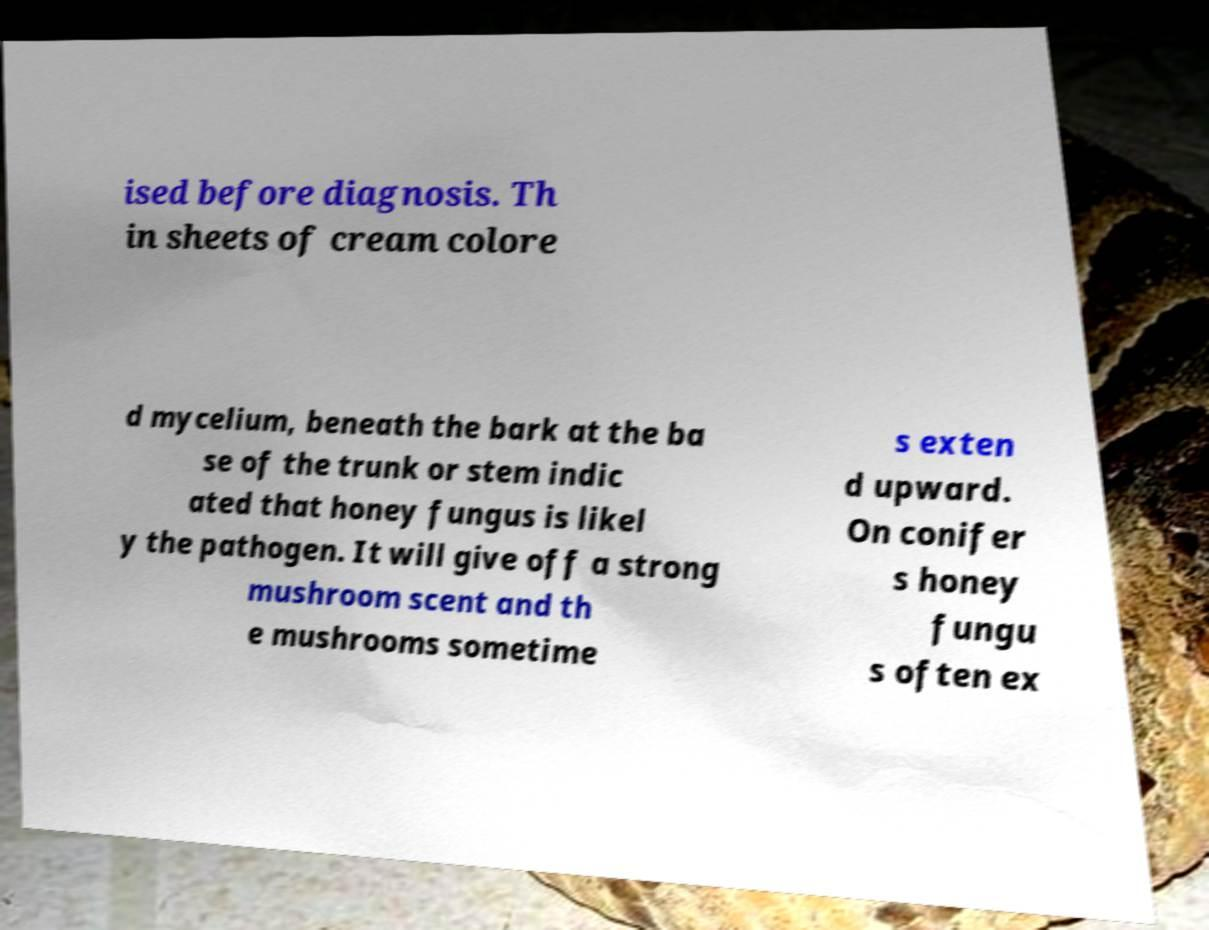For documentation purposes, I need the text within this image transcribed. Could you provide that? ised before diagnosis. Th in sheets of cream colore d mycelium, beneath the bark at the ba se of the trunk or stem indic ated that honey fungus is likel y the pathogen. It will give off a strong mushroom scent and th e mushrooms sometime s exten d upward. On conifer s honey fungu s often ex 